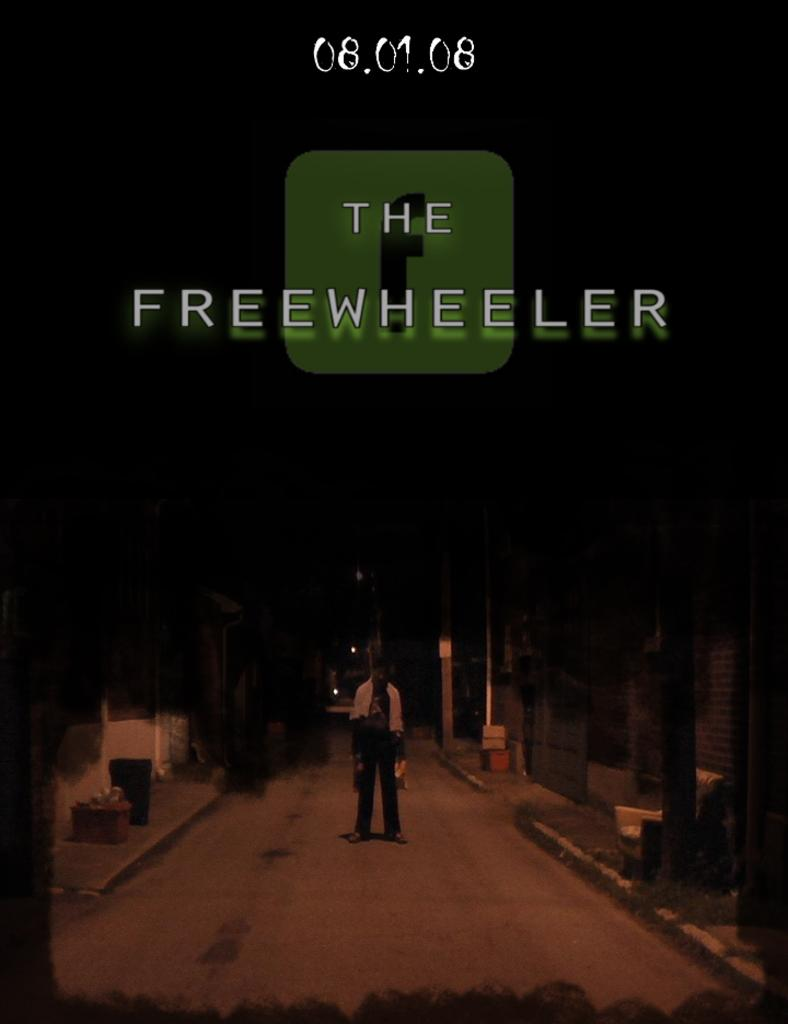<image>
Write a terse but informative summary of the picture. A sepia toned advertisement for the Freewheeler on 08-01-08 